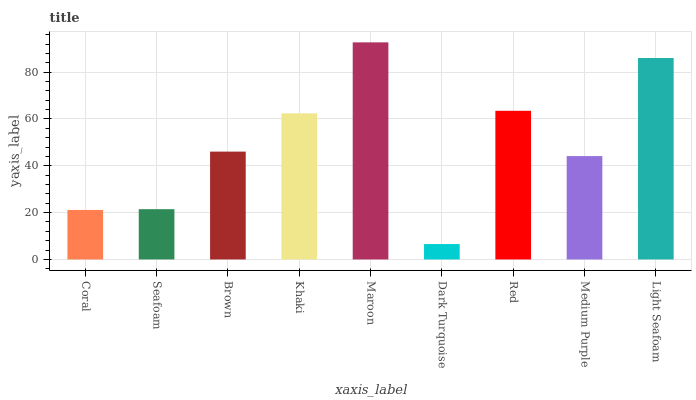Is Maroon the maximum?
Answer yes or no. Yes. Is Seafoam the minimum?
Answer yes or no. No. Is Seafoam the maximum?
Answer yes or no. No. Is Seafoam greater than Coral?
Answer yes or no. Yes. Is Coral less than Seafoam?
Answer yes or no. Yes. Is Coral greater than Seafoam?
Answer yes or no. No. Is Seafoam less than Coral?
Answer yes or no. No. Is Brown the high median?
Answer yes or no. Yes. Is Brown the low median?
Answer yes or no. Yes. Is Coral the high median?
Answer yes or no. No. Is Khaki the low median?
Answer yes or no. No. 